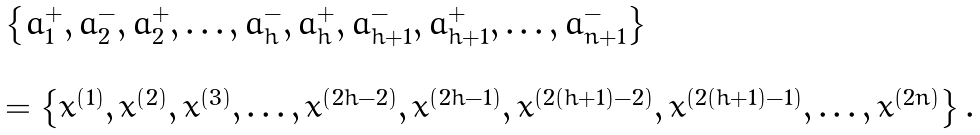Convert formula to latex. <formula><loc_0><loc_0><loc_500><loc_500>\begin{array} { l } \left \{ a _ { 1 } ^ { + } , a _ { 2 } ^ { - } , a _ { 2 } ^ { + } , \dots , a _ { h } ^ { - } , a _ { h } ^ { + } , a _ { h + 1 } ^ { - } , a _ { h + 1 } ^ { + } , \dots , a _ { n + 1 } ^ { - } \right \} \\ \\ = \left \{ x ^ { \left ( 1 \right ) } , x ^ { \left ( 2 \right ) } , x ^ { \left ( 3 \right ) } , \dots , x ^ { \left ( 2 h - 2 \right ) } , x ^ { \left ( 2 h - 1 \right ) } , x ^ { \left ( 2 \left ( h + 1 \right ) - 2 \right ) } , x ^ { \left ( 2 \left ( h + 1 \right ) - 1 \right ) } , \dots , x ^ { \left ( 2 n \right ) } \right \} . \end{array}</formula> 